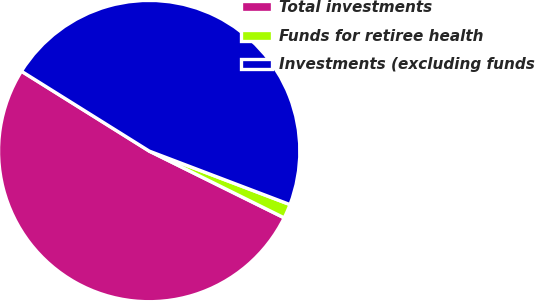<chart> <loc_0><loc_0><loc_500><loc_500><pie_chart><fcel>Total investments<fcel>Funds for retiree health<fcel>Investments (excluding funds<nl><fcel>51.58%<fcel>1.53%<fcel>46.89%<nl></chart> 